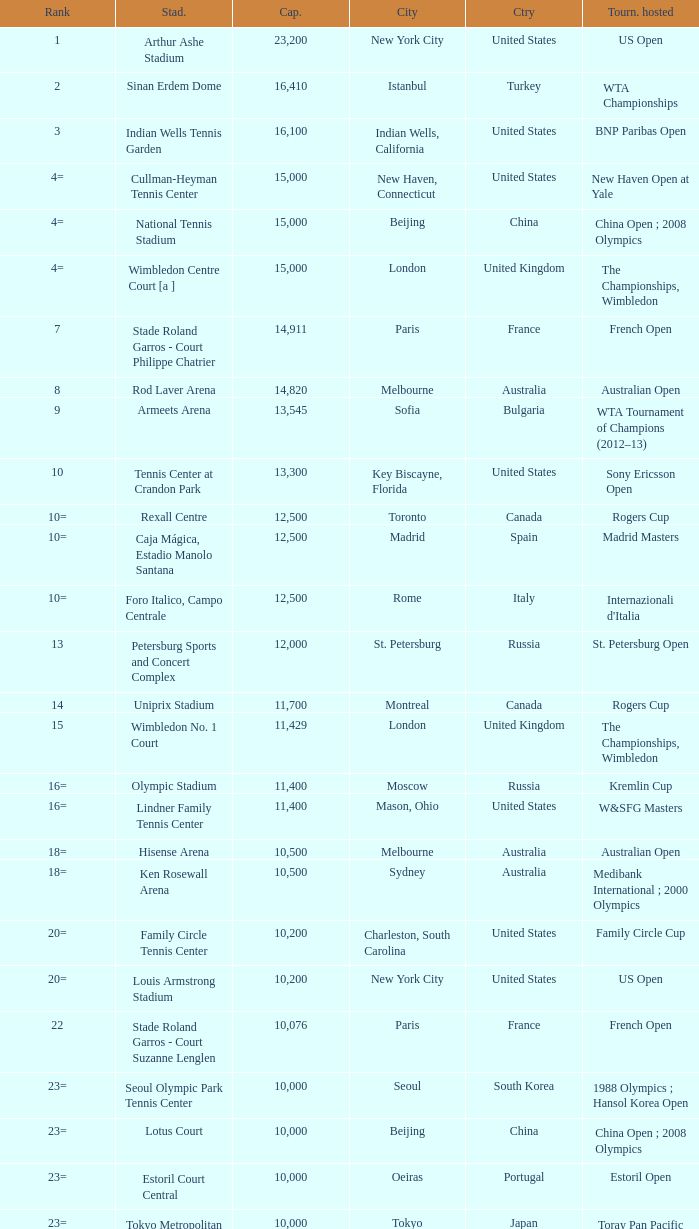What is the average capacity that has rod laver arena as the stadium? 14820.0. 